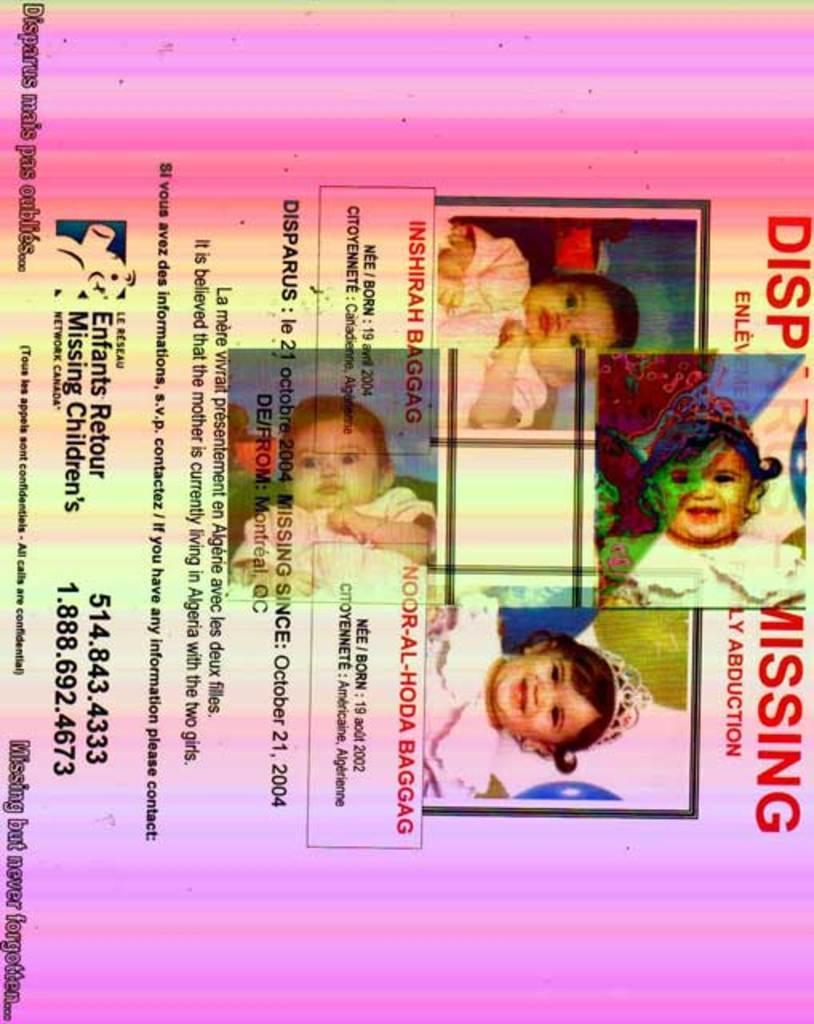Can you describe this image briefly? In the picture we can see a poster and on it we can see a the information about four children are missing. 